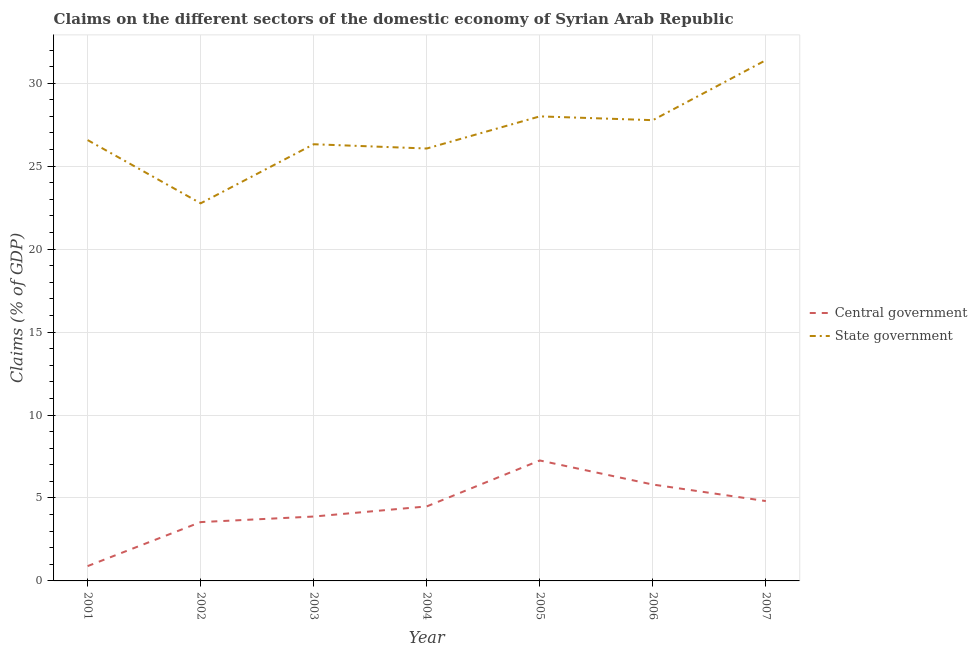How many different coloured lines are there?
Make the answer very short. 2. What is the claims on central government in 2001?
Your response must be concise. 0.89. Across all years, what is the maximum claims on state government?
Your answer should be very brief. 31.39. Across all years, what is the minimum claims on central government?
Keep it short and to the point. 0.89. In which year was the claims on central government minimum?
Provide a short and direct response. 2001. What is the total claims on state government in the graph?
Provide a short and direct response. 188.88. What is the difference between the claims on central government in 2006 and that in 2007?
Provide a succinct answer. 1. What is the difference between the claims on central government in 2003 and the claims on state government in 2007?
Ensure brevity in your answer.  -27.51. What is the average claims on central government per year?
Provide a short and direct response. 4.38. In the year 2004, what is the difference between the claims on state government and claims on central government?
Provide a succinct answer. 21.57. In how many years, is the claims on central government greater than 24 %?
Your answer should be very brief. 0. What is the ratio of the claims on state government in 2001 to that in 2002?
Offer a very short reply. 1.17. Is the claims on state government in 2003 less than that in 2006?
Your answer should be very brief. Yes. What is the difference between the highest and the second highest claims on state government?
Give a very brief answer. 3.39. What is the difference between the highest and the lowest claims on central government?
Provide a succinct answer. 6.37. Is the claims on central government strictly greater than the claims on state government over the years?
Provide a succinct answer. No. Is the claims on state government strictly less than the claims on central government over the years?
Ensure brevity in your answer.  No. How many years are there in the graph?
Your answer should be very brief. 7. What is the difference between two consecutive major ticks on the Y-axis?
Give a very brief answer. 5. Are the values on the major ticks of Y-axis written in scientific E-notation?
Your answer should be compact. No. Does the graph contain any zero values?
Your answer should be compact. No. Does the graph contain grids?
Your answer should be compact. Yes. Where does the legend appear in the graph?
Make the answer very short. Center right. What is the title of the graph?
Your response must be concise. Claims on the different sectors of the domestic economy of Syrian Arab Republic. What is the label or title of the X-axis?
Your response must be concise. Year. What is the label or title of the Y-axis?
Offer a very short reply. Claims (% of GDP). What is the Claims (% of GDP) in Central government in 2001?
Offer a terse response. 0.89. What is the Claims (% of GDP) of State government in 2001?
Provide a short and direct response. 26.57. What is the Claims (% of GDP) in Central government in 2002?
Your answer should be very brief. 3.55. What is the Claims (% of GDP) of State government in 2002?
Give a very brief answer. 22.76. What is the Claims (% of GDP) of Central government in 2003?
Offer a very short reply. 3.88. What is the Claims (% of GDP) in State government in 2003?
Make the answer very short. 26.32. What is the Claims (% of GDP) in Central government in 2004?
Give a very brief answer. 4.49. What is the Claims (% of GDP) in State government in 2004?
Offer a terse response. 26.06. What is the Claims (% of GDP) of Central government in 2005?
Make the answer very short. 7.26. What is the Claims (% of GDP) of State government in 2005?
Ensure brevity in your answer.  28. What is the Claims (% of GDP) in Central government in 2006?
Give a very brief answer. 5.81. What is the Claims (% of GDP) of State government in 2006?
Make the answer very short. 27.77. What is the Claims (% of GDP) in Central government in 2007?
Your answer should be compact. 4.81. What is the Claims (% of GDP) in State government in 2007?
Your response must be concise. 31.39. Across all years, what is the maximum Claims (% of GDP) of Central government?
Your answer should be very brief. 7.26. Across all years, what is the maximum Claims (% of GDP) of State government?
Provide a succinct answer. 31.39. Across all years, what is the minimum Claims (% of GDP) in Central government?
Ensure brevity in your answer.  0.89. Across all years, what is the minimum Claims (% of GDP) of State government?
Ensure brevity in your answer.  22.76. What is the total Claims (% of GDP) of Central government in the graph?
Offer a terse response. 30.69. What is the total Claims (% of GDP) of State government in the graph?
Offer a terse response. 188.88. What is the difference between the Claims (% of GDP) of Central government in 2001 and that in 2002?
Your response must be concise. -2.65. What is the difference between the Claims (% of GDP) of State government in 2001 and that in 2002?
Your response must be concise. 3.81. What is the difference between the Claims (% of GDP) of Central government in 2001 and that in 2003?
Your answer should be compact. -2.99. What is the difference between the Claims (% of GDP) of State government in 2001 and that in 2003?
Provide a short and direct response. 0.25. What is the difference between the Claims (% of GDP) of Central government in 2001 and that in 2004?
Your answer should be compact. -3.6. What is the difference between the Claims (% of GDP) of State government in 2001 and that in 2004?
Offer a terse response. 0.51. What is the difference between the Claims (% of GDP) in Central government in 2001 and that in 2005?
Your answer should be compact. -6.37. What is the difference between the Claims (% of GDP) in State government in 2001 and that in 2005?
Make the answer very short. -1.43. What is the difference between the Claims (% of GDP) of Central government in 2001 and that in 2006?
Ensure brevity in your answer.  -4.92. What is the difference between the Claims (% of GDP) in State government in 2001 and that in 2006?
Offer a terse response. -1.2. What is the difference between the Claims (% of GDP) in Central government in 2001 and that in 2007?
Keep it short and to the point. -3.92. What is the difference between the Claims (% of GDP) in State government in 2001 and that in 2007?
Your response must be concise. -4.82. What is the difference between the Claims (% of GDP) in Central government in 2002 and that in 2003?
Your response must be concise. -0.33. What is the difference between the Claims (% of GDP) in State government in 2002 and that in 2003?
Keep it short and to the point. -3.56. What is the difference between the Claims (% of GDP) of Central government in 2002 and that in 2004?
Give a very brief answer. -0.94. What is the difference between the Claims (% of GDP) of State government in 2002 and that in 2004?
Provide a succinct answer. -3.3. What is the difference between the Claims (% of GDP) of Central government in 2002 and that in 2005?
Your answer should be very brief. -3.71. What is the difference between the Claims (% of GDP) of State government in 2002 and that in 2005?
Your answer should be very brief. -5.24. What is the difference between the Claims (% of GDP) in Central government in 2002 and that in 2006?
Keep it short and to the point. -2.26. What is the difference between the Claims (% of GDP) in State government in 2002 and that in 2006?
Offer a terse response. -5.01. What is the difference between the Claims (% of GDP) in Central government in 2002 and that in 2007?
Your response must be concise. -1.27. What is the difference between the Claims (% of GDP) of State government in 2002 and that in 2007?
Your answer should be compact. -8.63. What is the difference between the Claims (% of GDP) in Central government in 2003 and that in 2004?
Offer a very short reply. -0.61. What is the difference between the Claims (% of GDP) of State government in 2003 and that in 2004?
Your answer should be compact. 0.26. What is the difference between the Claims (% of GDP) of Central government in 2003 and that in 2005?
Offer a terse response. -3.38. What is the difference between the Claims (% of GDP) in State government in 2003 and that in 2005?
Provide a succinct answer. -1.68. What is the difference between the Claims (% of GDP) in Central government in 2003 and that in 2006?
Your answer should be very brief. -1.93. What is the difference between the Claims (% of GDP) in State government in 2003 and that in 2006?
Offer a terse response. -1.45. What is the difference between the Claims (% of GDP) of Central government in 2003 and that in 2007?
Offer a very short reply. -0.93. What is the difference between the Claims (% of GDP) in State government in 2003 and that in 2007?
Offer a very short reply. -5.07. What is the difference between the Claims (% of GDP) of Central government in 2004 and that in 2005?
Make the answer very short. -2.77. What is the difference between the Claims (% of GDP) of State government in 2004 and that in 2005?
Your answer should be very brief. -1.94. What is the difference between the Claims (% of GDP) in Central government in 2004 and that in 2006?
Your response must be concise. -1.32. What is the difference between the Claims (% of GDP) of State government in 2004 and that in 2006?
Keep it short and to the point. -1.71. What is the difference between the Claims (% of GDP) in Central government in 2004 and that in 2007?
Offer a very short reply. -0.32. What is the difference between the Claims (% of GDP) in State government in 2004 and that in 2007?
Your answer should be very brief. -5.33. What is the difference between the Claims (% of GDP) in Central government in 2005 and that in 2006?
Offer a terse response. 1.45. What is the difference between the Claims (% of GDP) of State government in 2005 and that in 2006?
Give a very brief answer. 0.23. What is the difference between the Claims (% of GDP) in Central government in 2005 and that in 2007?
Offer a very short reply. 2.45. What is the difference between the Claims (% of GDP) of State government in 2005 and that in 2007?
Your answer should be very brief. -3.39. What is the difference between the Claims (% of GDP) in State government in 2006 and that in 2007?
Your answer should be very brief. -3.62. What is the difference between the Claims (% of GDP) in Central government in 2001 and the Claims (% of GDP) in State government in 2002?
Your response must be concise. -21.87. What is the difference between the Claims (% of GDP) in Central government in 2001 and the Claims (% of GDP) in State government in 2003?
Your answer should be very brief. -25.43. What is the difference between the Claims (% of GDP) in Central government in 2001 and the Claims (% of GDP) in State government in 2004?
Provide a short and direct response. -25.17. What is the difference between the Claims (% of GDP) of Central government in 2001 and the Claims (% of GDP) of State government in 2005?
Provide a short and direct response. -27.11. What is the difference between the Claims (% of GDP) in Central government in 2001 and the Claims (% of GDP) in State government in 2006?
Make the answer very short. -26.88. What is the difference between the Claims (% of GDP) in Central government in 2001 and the Claims (% of GDP) in State government in 2007?
Keep it short and to the point. -30.5. What is the difference between the Claims (% of GDP) of Central government in 2002 and the Claims (% of GDP) of State government in 2003?
Your answer should be very brief. -22.78. What is the difference between the Claims (% of GDP) in Central government in 2002 and the Claims (% of GDP) in State government in 2004?
Provide a short and direct response. -22.52. What is the difference between the Claims (% of GDP) in Central government in 2002 and the Claims (% of GDP) in State government in 2005?
Make the answer very short. -24.46. What is the difference between the Claims (% of GDP) in Central government in 2002 and the Claims (% of GDP) in State government in 2006?
Give a very brief answer. -24.23. What is the difference between the Claims (% of GDP) of Central government in 2002 and the Claims (% of GDP) of State government in 2007?
Your response must be concise. -27.84. What is the difference between the Claims (% of GDP) in Central government in 2003 and the Claims (% of GDP) in State government in 2004?
Offer a terse response. -22.18. What is the difference between the Claims (% of GDP) in Central government in 2003 and the Claims (% of GDP) in State government in 2005?
Ensure brevity in your answer.  -24.12. What is the difference between the Claims (% of GDP) in Central government in 2003 and the Claims (% of GDP) in State government in 2006?
Ensure brevity in your answer.  -23.89. What is the difference between the Claims (% of GDP) of Central government in 2003 and the Claims (% of GDP) of State government in 2007?
Your answer should be compact. -27.51. What is the difference between the Claims (% of GDP) of Central government in 2004 and the Claims (% of GDP) of State government in 2005?
Offer a very short reply. -23.51. What is the difference between the Claims (% of GDP) of Central government in 2004 and the Claims (% of GDP) of State government in 2006?
Ensure brevity in your answer.  -23.28. What is the difference between the Claims (% of GDP) in Central government in 2004 and the Claims (% of GDP) in State government in 2007?
Give a very brief answer. -26.9. What is the difference between the Claims (% of GDP) in Central government in 2005 and the Claims (% of GDP) in State government in 2006?
Give a very brief answer. -20.51. What is the difference between the Claims (% of GDP) of Central government in 2005 and the Claims (% of GDP) of State government in 2007?
Keep it short and to the point. -24.13. What is the difference between the Claims (% of GDP) in Central government in 2006 and the Claims (% of GDP) in State government in 2007?
Your response must be concise. -25.58. What is the average Claims (% of GDP) in Central government per year?
Your answer should be compact. 4.38. What is the average Claims (% of GDP) in State government per year?
Your answer should be compact. 26.98. In the year 2001, what is the difference between the Claims (% of GDP) in Central government and Claims (% of GDP) in State government?
Ensure brevity in your answer.  -25.68. In the year 2002, what is the difference between the Claims (% of GDP) in Central government and Claims (% of GDP) in State government?
Offer a very short reply. -19.21. In the year 2003, what is the difference between the Claims (% of GDP) in Central government and Claims (% of GDP) in State government?
Keep it short and to the point. -22.44. In the year 2004, what is the difference between the Claims (% of GDP) of Central government and Claims (% of GDP) of State government?
Ensure brevity in your answer.  -21.57. In the year 2005, what is the difference between the Claims (% of GDP) of Central government and Claims (% of GDP) of State government?
Offer a very short reply. -20.74. In the year 2006, what is the difference between the Claims (% of GDP) in Central government and Claims (% of GDP) in State government?
Your answer should be very brief. -21.96. In the year 2007, what is the difference between the Claims (% of GDP) of Central government and Claims (% of GDP) of State government?
Your answer should be very brief. -26.58. What is the ratio of the Claims (% of GDP) in Central government in 2001 to that in 2002?
Ensure brevity in your answer.  0.25. What is the ratio of the Claims (% of GDP) in State government in 2001 to that in 2002?
Offer a very short reply. 1.17. What is the ratio of the Claims (% of GDP) of Central government in 2001 to that in 2003?
Provide a succinct answer. 0.23. What is the ratio of the Claims (% of GDP) in State government in 2001 to that in 2003?
Provide a succinct answer. 1.01. What is the ratio of the Claims (% of GDP) in Central government in 2001 to that in 2004?
Offer a very short reply. 0.2. What is the ratio of the Claims (% of GDP) in State government in 2001 to that in 2004?
Your answer should be compact. 1.02. What is the ratio of the Claims (% of GDP) of Central government in 2001 to that in 2005?
Ensure brevity in your answer.  0.12. What is the ratio of the Claims (% of GDP) of State government in 2001 to that in 2005?
Provide a short and direct response. 0.95. What is the ratio of the Claims (% of GDP) of Central government in 2001 to that in 2006?
Provide a short and direct response. 0.15. What is the ratio of the Claims (% of GDP) in State government in 2001 to that in 2006?
Your answer should be compact. 0.96. What is the ratio of the Claims (% of GDP) of Central government in 2001 to that in 2007?
Your answer should be compact. 0.19. What is the ratio of the Claims (% of GDP) of State government in 2001 to that in 2007?
Ensure brevity in your answer.  0.85. What is the ratio of the Claims (% of GDP) of Central government in 2002 to that in 2003?
Make the answer very short. 0.91. What is the ratio of the Claims (% of GDP) of State government in 2002 to that in 2003?
Make the answer very short. 0.86. What is the ratio of the Claims (% of GDP) in Central government in 2002 to that in 2004?
Provide a succinct answer. 0.79. What is the ratio of the Claims (% of GDP) in State government in 2002 to that in 2004?
Offer a very short reply. 0.87. What is the ratio of the Claims (% of GDP) of Central government in 2002 to that in 2005?
Your response must be concise. 0.49. What is the ratio of the Claims (% of GDP) in State government in 2002 to that in 2005?
Your answer should be compact. 0.81. What is the ratio of the Claims (% of GDP) of Central government in 2002 to that in 2006?
Give a very brief answer. 0.61. What is the ratio of the Claims (% of GDP) of State government in 2002 to that in 2006?
Provide a succinct answer. 0.82. What is the ratio of the Claims (% of GDP) in Central government in 2002 to that in 2007?
Offer a very short reply. 0.74. What is the ratio of the Claims (% of GDP) in State government in 2002 to that in 2007?
Provide a succinct answer. 0.73. What is the ratio of the Claims (% of GDP) in Central government in 2003 to that in 2004?
Make the answer very short. 0.86. What is the ratio of the Claims (% of GDP) of State government in 2003 to that in 2004?
Your response must be concise. 1.01. What is the ratio of the Claims (% of GDP) of Central government in 2003 to that in 2005?
Your answer should be very brief. 0.53. What is the ratio of the Claims (% of GDP) in Central government in 2003 to that in 2006?
Offer a terse response. 0.67. What is the ratio of the Claims (% of GDP) of State government in 2003 to that in 2006?
Your response must be concise. 0.95. What is the ratio of the Claims (% of GDP) of Central government in 2003 to that in 2007?
Offer a terse response. 0.81. What is the ratio of the Claims (% of GDP) of State government in 2003 to that in 2007?
Provide a succinct answer. 0.84. What is the ratio of the Claims (% of GDP) of Central government in 2004 to that in 2005?
Your response must be concise. 0.62. What is the ratio of the Claims (% of GDP) of State government in 2004 to that in 2005?
Your answer should be compact. 0.93. What is the ratio of the Claims (% of GDP) of Central government in 2004 to that in 2006?
Your response must be concise. 0.77. What is the ratio of the Claims (% of GDP) of State government in 2004 to that in 2006?
Your answer should be very brief. 0.94. What is the ratio of the Claims (% of GDP) in Central government in 2004 to that in 2007?
Offer a terse response. 0.93. What is the ratio of the Claims (% of GDP) in State government in 2004 to that in 2007?
Your response must be concise. 0.83. What is the ratio of the Claims (% of GDP) of Central government in 2005 to that in 2006?
Keep it short and to the point. 1.25. What is the ratio of the Claims (% of GDP) of State government in 2005 to that in 2006?
Your response must be concise. 1.01. What is the ratio of the Claims (% of GDP) in Central government in 2005 to that in 2007?
Make the answer very short. 1.51. What is the ratio of the Claims (% of GDP) in State government in 2005 to that in 2007?
Offer a very short reply. 0.89. What is the ratio of the Claims (% of GDP) of Central government in 2006 to that in 2007?
Your answer should be very brief. 1.21. What is the ratio of the Claims (% of GDP) in State government in 2006 to that in 2007?
Offer a terse response. 0.88. What is the difference between the highest and the second highest Claims (% of GDP) in Central government?
Keep it short and to the point. 1.45. What is the difference between the highest and the second highest Claims (% of GDP) of State government?
Your answer should be very brief. 3.39. What is the difference between the highest and the lowest Claims (% of GDP) of Central government?
Your answer should be very brief. 6.37. What is the difference between the highest and the lowest Claims (% of GDP) in State government?
Provide a succinct answer. 8.63. 